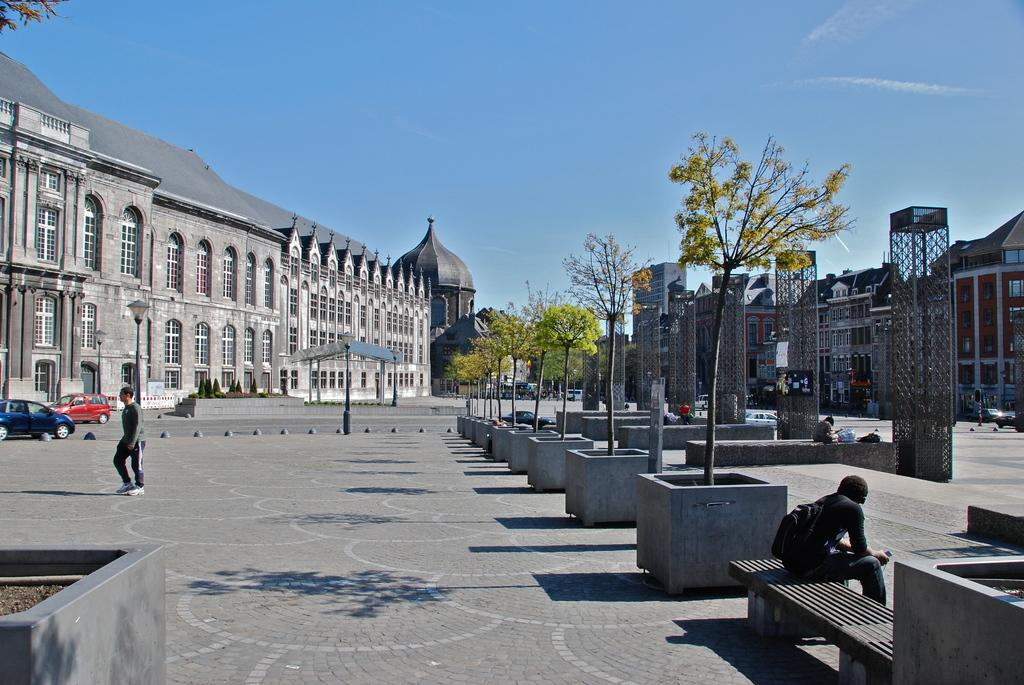How many persons can be seen in the image? There are persons in the image, but the exact number is not specified. What type of natural elements are present in the image? There are trees in the image. What type of man-made structures are present in the image? There are buildings in the image. What can be found in the right corner of the image? There are other objects in the right corner of the image. Where is the person standing in the image? There is a person standing in the left corner of the image. What type of vehicles are present in the left corner of the image? There are two cars in the left corner of the image. What type of man-made structure is present in the left corner of the image? There is a building in the left corner of the image. What type of bait is being used by the person standing in the left corner of the image? There is no indication in the image that the person standing in the left corner is using bait or engaging in any fishing-related activity. 